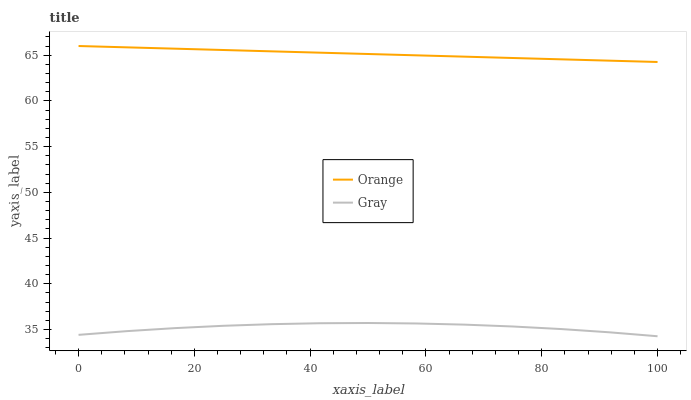Does Gray have the minimum area under the curve?
Answer yes or no. Yes. Does Orange have the maximum area under the curve?
Answer yes or no. Yes. Does Gray have the maximum area under the curve?
Answer yes or no. No. Is Orange the smoothest?
Answer yes or no. Yes. Is Gray the roughest?
Answer yes or no. Yes. Is Gray the smoothest?
Answer yes or no. No. Does Gray have the lowest value?
Answer yes or no. Yes. Does Orange have the highest value?
Answer yes or no. Yes. Does Gray have the highest value?
Answer yes or no. No. Is Gray less than Orange?
Answer yes or no. Yes. Is Orange greater than Gray?
Answer yes or no. Yes. Does Gray intersect Orange?
Answer yes or no. No. 